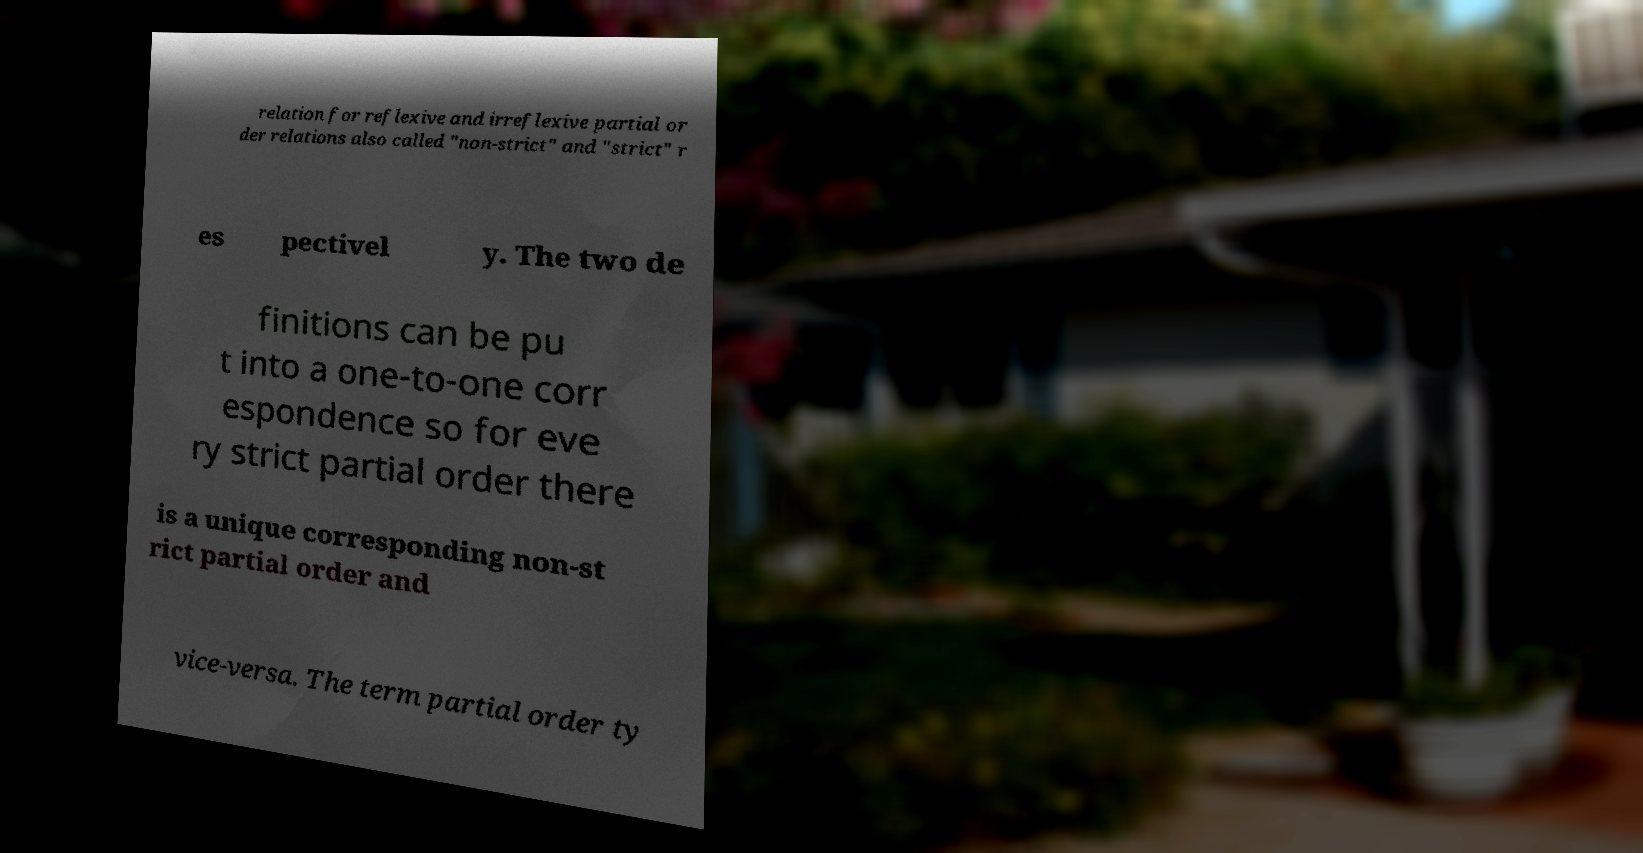Can you read and provide the text displayed in the image?This photo seems to have some interesting text. Can you extract and type it out for me? relation for reflexive and irreflexive partial or der relations also called "non-strict" and "strict" r es pectivel y. The two de finitions can be pu t into a one-to-one corr espondence so for eve ry strict partial order there is a unique corresponding non-st rict partial order and vice-versa. The term partial order ty 